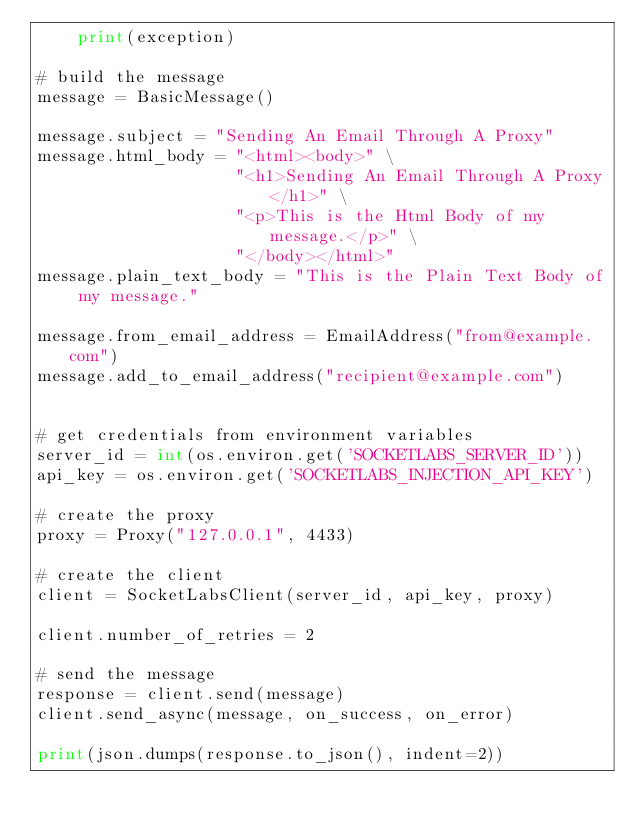Convert code to text. <code><loc_0><loc_0><loc_500><loc_500><_Python_>    print(exception) 

# build the message
message = BasicMessage()

message.subject = "Sending An Email Through A Proxy"
message.html_body = "<html><body>" \
                    "<h1>Sending An Email Through A Proxy</h1>" \
                    "<p>This is the Html Body of my message.</p>" \
                    "</body></html>"
message.plain_text_body = "This is the Plain Text Body of my message."

message.from_email_address = EmailAddress("from@example.com")
message.add_to_email_address("recipient@example.com")


# get credentials from environment variables
server_id = int(os.environ.get('SOCKETLABS_SERVER_ID'))
api_key = os.environ.get('SOCKETLABS_INJECTION_API_KEY')

# create the proxy
proxy = Proxy("127.0.0.1", 4433)

# create the client
client = SocketLabsClient(server_id, api_key, proxy)

client.number_of_retries = 2

# send the message
response = client.send(message)
client.send_async(message, on_success, on_error)

print(json.dumps(response.to_json(), indent=2))
</code> 